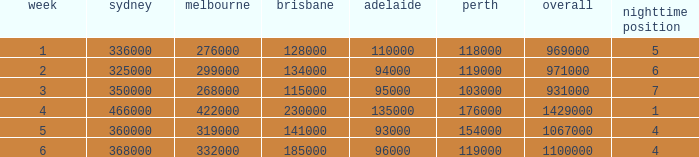What was the total rating on week 3?  931000.0. 